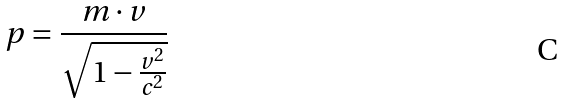Convert formula to latex. <formula><loc_0><loc_0><loc_500><loc_500>p = \frac { m \cdot v } { \sqrt { 1 - \frac { v ^ { 2 } } { c ^ { 2 } } } }</formula> 